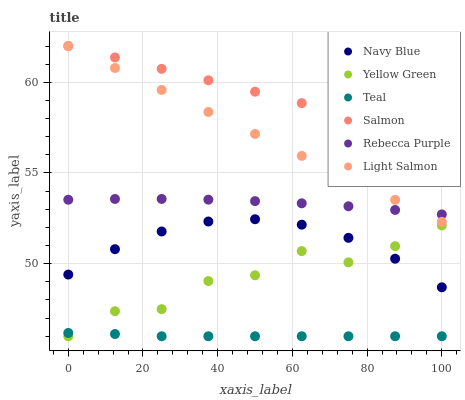Does Teal have the minimum area under the curve?
Answer yes or no. Yes. Does Salmon have the maximum area under the curve?
Answer yes or no. Yes. Does Yellow Green have the minimum area under the curve?
Answer yes or no. No. Does Yellow Green have the maximum area under the curve?
Answer yes or no. No. Is Light Salmon the smoothest?
Answer yes or no. Yes. Is Yellow Green the roughest?
Answer yes or no. Yes. Is Navy Blue the smoothest?
Answer yes or no. No. Is Navy Blue the roughest?
Answer yes or no. No. Does Yellow Green have the lowest value?
Answer yes or no. Yes. Does Navy Blue have the lowest value?
Answer yes or no. No. Does Salmon have the highest value?
Answer yes or no. Yes. Does Yellow Green have the highest value?
Answer yes or no. No. Is Teal less than Light Salmon?
Answer yes or no. Yes. Is Salmon greater than Rebecca Purple?
Answer yes or no. Yes. Does Rebecca Purple intersect Light Salmon?
Answer yes or no. Yes. Is Rebecca Purple less than Light Salmon?
Answer yes or no. No. Is Rebecca Purple greater than Light Salmon?
Answer yes or no. No. Does Teal intersect Light Salmon?
Answer yes or no. No. 